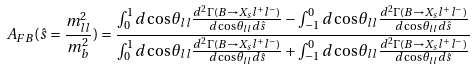<formula> <loc_0><loc_0><loc_500><loc_500>A _ { F B } ( \hat { s } = \frac { m ^ { 2 } _ { l l } } { m ^ { 2 } _ { b } } ) = \frac { \int _ { 0 } ^ { 1 } d \cos \theta _ { l l } \frac { d ^ { 2 } \Gamma ( B \to X _ { s } l ^ { + } l ^ { - } ) } { d \cos \theta _ { l l } d \hat { s } } - \int _ { - 1 } ^ { 0 } d \cos \theta _ { l l } \frac { d ^ { 2 } \Gamma ( B \to X _ { s } l ^ { + } l ^ { - } ) } { d \cos \theta _ { l l } d \hat { s } } } { \int _ { 0 } ^ { 1 } d \cos \theta _ { l l } \frac { d ^ { 2 } \Gamma ( B \to X _ { s } l ^ { + } l ^ { - } ) } { d \cos \theta _ { l l } d \hat { s } } + \int _ { - 1 } ^ { 0 } d \cos \theta _ { l l } \frac { d ^ { 2 } \Gamma ( B \to X _ { s } l ^ { + } l ^ { - } ) } { d \cos \theta _ { l l } d \hat { s } } }</formula> 